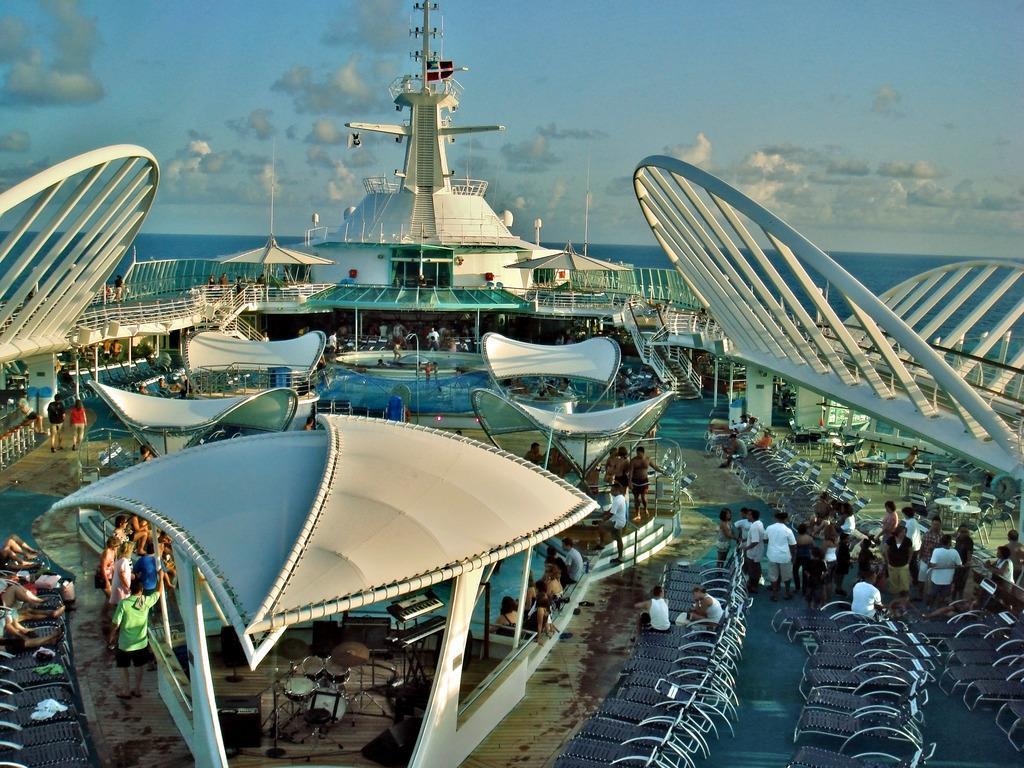How would you summarize this image in a sentence or two? In this picture, we see many people are standing. Beside them, we see many chairs and musical instruments are placed under the white color shed like structure. On the left side, we see the chairs and a man is sitting on the chair. Beside him, we see two people are standing. In the middle, we see water. On the right side, we see the staircase and the stair railing. In the middle, we see a tower. In the background, we see water and this water might be in the sea. At the top, we see the sky and the clouds. 